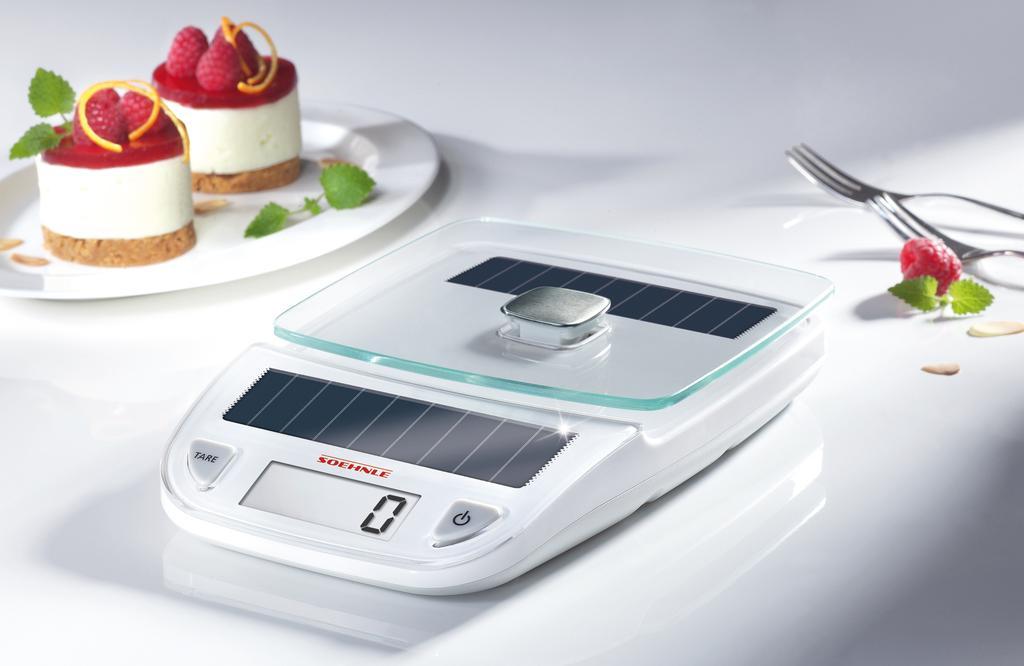Can you describe this image briefly? In this image I can see the white colored surface on which I can see a white colored plate and on the plate I can see few herbs and two food items which are red, orange, white and brown in color. I can see two forks, a berry which is red in color and a weighing machine which is white and black in color. 